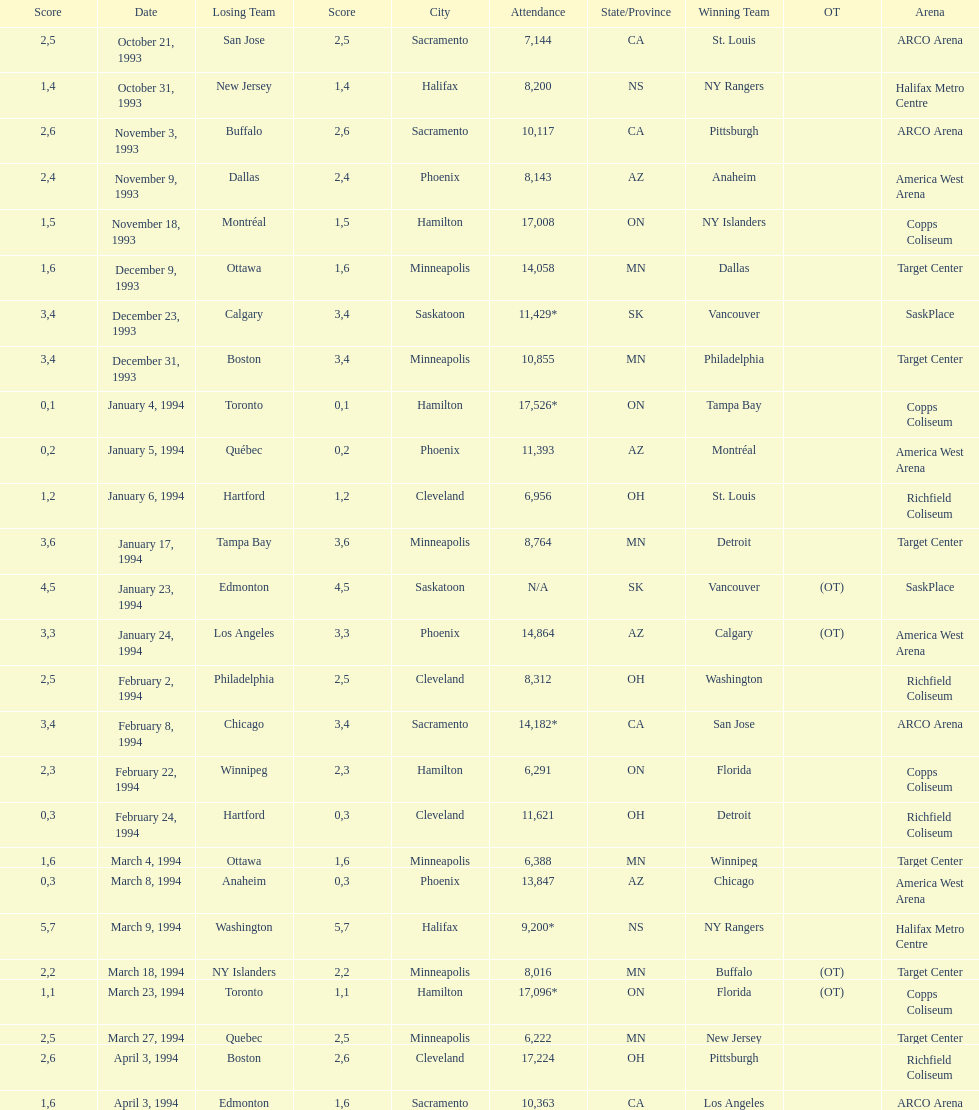Can you parse all the data within this table? {'header': ['Score', 'Date', 'Losing Team', 'Score', 'City', 'Attendance', 'State/Province', 'Winning Team', 'OT', 'Arena'], 'rows': [['2', 'October 21, 1993', 'San Jose', '5', 'Sacramento', '7,144', 'CA', 'St. Louis', '', 'ARCO Arena'], ['1', 'October 31, 1993', 'New Jersey', '4', 'Halifax', '8,200', 'NS', 'NY Rangers', '', 'Halifax Metro Centre'], ['2', 'November 3, 1993', 'Buffalo', '6', 'Sacramento', '10,117', 'CA', 'Pittsburgh', '', 'ARCO Arena'], ['2', 'November 9, 1993', 'Dallas', '4', 'Phoenix', '8,143', 'AZ', 'Anaheim', '', 'America West Arena'], ['1', 'November 18, 1993', 'Montréal', '5', 'Hamilton', '17,008', 'ON', 'NY Islanders', '', 'Copps Coliseum'], ['1', 'December 9, 1993', 'Ottawa', '6', 'Minneapolis', '14,058', 'MN', 'Dallas', '', 'Target Center'], ['3', 'December 23, 1993', 'Calgary', '4', 'Saskatoon', '11,429*', 'SK', 'Vancouver', '', 'SaskPlace'], ['3', 'December 31, 1993', 'Boston', '4', 'Minneapolis', '10,855', 'MN', 'Philadelphia', '', 'Target Center'], ['0', 'January 4, 1994', 'Toronto', '1', 'Hamilton', '17,526*', 'ON', 'Tampa Bay', '', 'Copps Coliseum'], ['0', 'January 5, 1994', 'Québec', '2', 'Phoenix', '11,393', 'AZ', 'Montréal', '', 'America West Arena'], ['1', 'January 6, 1994', 'Hartford', '2', 'Cleveland', '6,956', 'OH', 'St. Louis', '', 'Richfield Coliseum'], ['3', 'January 17, 1994', 'Tampa Bay', '6', 'Minneapolis', '8,764', 'MN', 'Detroit', '', 'Target Center'], ['4', 'January 23, 1994', 'Edmonton', '5', 'Saskatoon', 'N/A', 'SK', 'Vancouver', '(OT)', 'SaskPlace'], ['3', 'January 24, 1994', 'Los Angeles', '3', 'Phoenix', '14,864', 'AZ', 'Calgary', '(OT)', 'America West Arena'], ['2', 'February 2, 1994', 'Philadelphia', '5', 'Cleveland', '8,312', 'OH', 'Washington', '', 'Richfield Coliseum'], ['3', 'February 8, 1994', 'Chicago', '4', 'Sacramento', '14,182*', 'CA', 'San Jose', '', 'ARCO Arena'], ['2', 'February 22, 1994', 'Winnipeg', '3', 'Hamilton', '6,291', 'ON', 'Florida', '', 'Copps Coliseum'], ['0', 'February 24, 1994', 'Hartford', '3', 'Cleveland', '11,621', 'OH', 'Detroit', '', 'Richfield Coliseum'], ['1', 'March 4, 1994', 'Ottawa', '6', 'Minneapolis', '6,388', 'MN', 'Winnipeg', '', 'Target Center'], ['0', 'March 8, 1994', 'Anaheim', '3', 'Phoenix', '13,847', 'AZ', 'Chicago', '', 'America West Arena'], ['5', 'March 9, 1994', 'Washington', '7', 'Halifax', '9,200*', 'NS', 'NY Rangers', '', 'Halifax Metro Centre'], ['2', 'March 18, 1994', 'NY Islanders', '2', 'Minneapolis', '8,016', 'MN', 'Buffalo', '(OT)', 'Target Center'], ['1', 'March 23, 1994', 'Toronto', '1', 'Hamilton', '17,096*', 'ON', 'Florida', '(OT)', 'Copps Coliseum'], ['2', 'March 27, 1994', 'Quebec', '5', 'Minneapolis', '6,222', 'MN', 'New Jersey', '', 'Target Center'], ['2', 'April 3, 1994', 'Boston', '6', 'Cleveland', '17,224', 'OH', 'Pittsburgh', '', 'Richfield Coliseum'], ['1', 'April 3, 1994', 'Edmonton', '6', 'Sacramento', '10,363', 'CA', 'Los Angeles', '', 'ARCO Arena']]} How many games have been held in minneapolis? 6. 